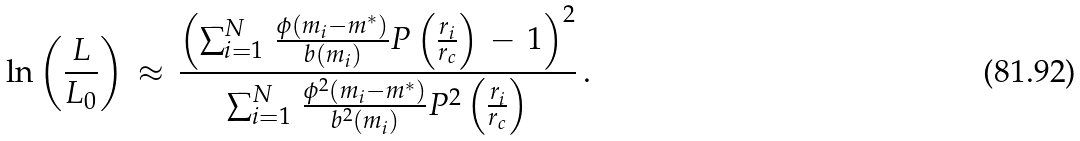<formula> <loc_0><loc_0><loc_500><loc_500>\ln \left ( \frac { L } { L _ { 0 } } \right ) \, \approx \, \frac { \left ( \sum _ { i = 1 } ^ { N } \, \frac { \phi ( m _ { i } - m ^ { * } ) } { b ( m _ { i } ) } P \left ( \frac { r _ { i } } { r _ { c } } \right ) \, - \, 1 \right ) ^ { 2 } } { \sum _ { i = 1 } ^ { N } \, \frac { \phi ^ { 2 } ( m _ { i } - m ^ { * } ) } { b ^ { 2 } ( m _ { i } ) } P ^ { 2 } \left ( \frac { r _ { i } } { r _ { c } } \right ) } \, .</formula> 